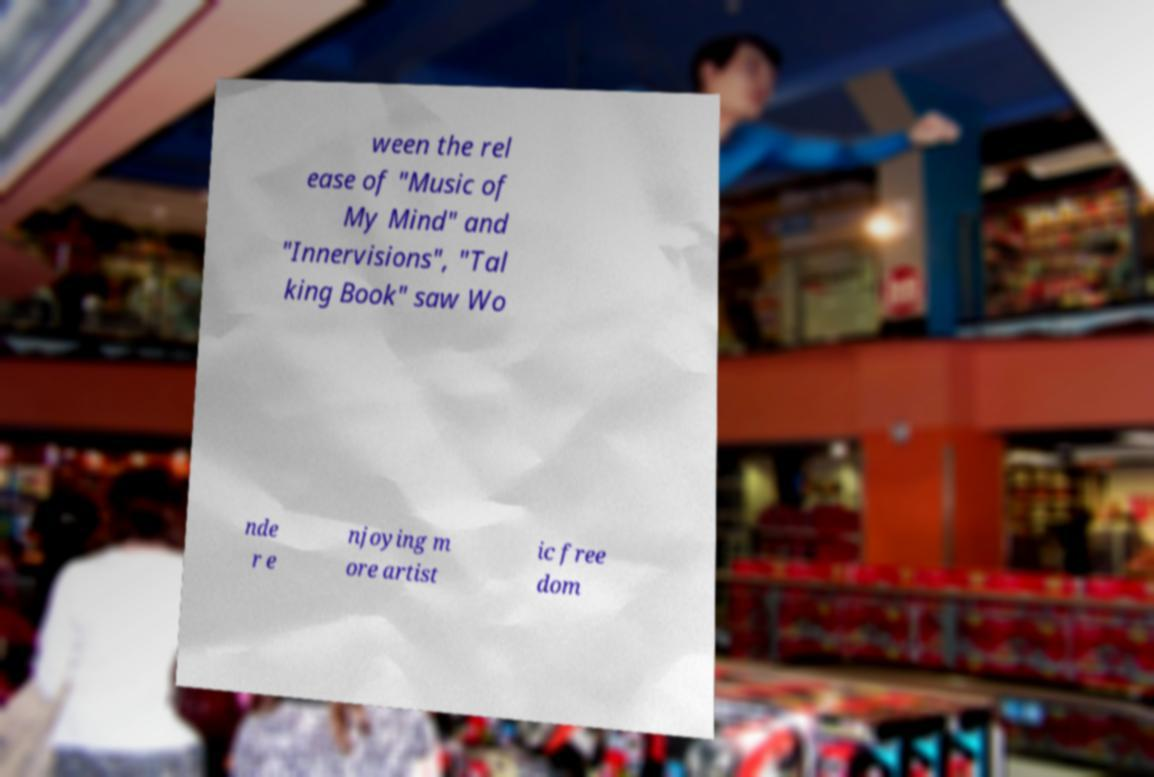Can you read and provide the text displayed in the image?This photo seems to have some interesting text. Can you extract and type it out for me? ween the rel ease of "Music of My Mind" and "Innervisions", "Tal king Book" saw Wo nde r e njoying m ore artist ic free dom 